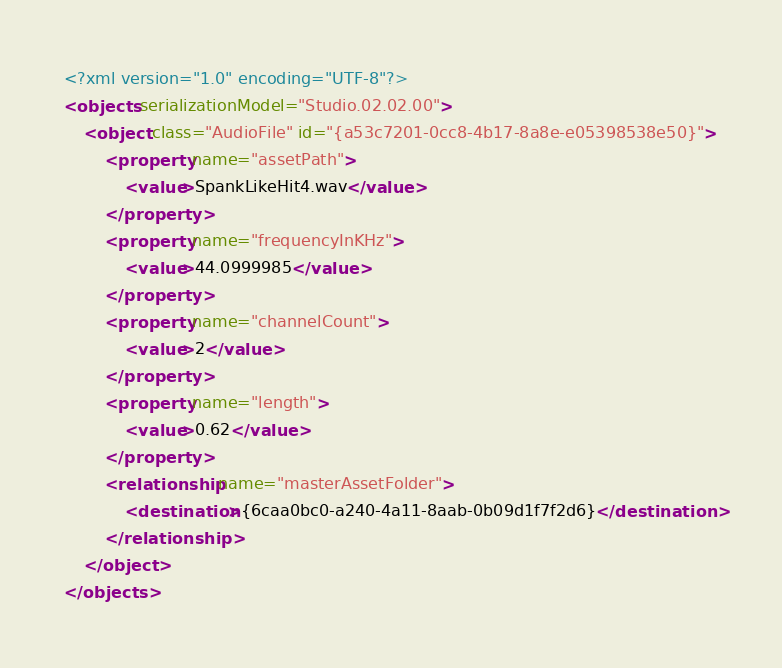<code> <loc_0><loc_0><loc_500><loc_500><_XML_><?xml version="1.0" encoding="UTF-8"?>
<objects serializationModel="Studio.02.02.00">
	<object class="AudioFile" id="{a53c7201-0cc8-4b17-8a8e-e05398538e50}">
		<property name="assetPath">
			<value>SpankLikeHit4.wav</value>
		</property>
		<property name="frequencyInKHz">
			<value>44.0999985</value>
		</property>
		<property name="channelCount">
			<value>2</value>
		</property>
		<property name="length">
			<value>0.62</value>
		</property>
		<relationship name="masterAssetFolder">
			<destination>{6caa0bc0-a240-4a11-8aab-0b09d1f7f2d6}</destination>
		</relationship>
	</object>
</objects>
</code> 